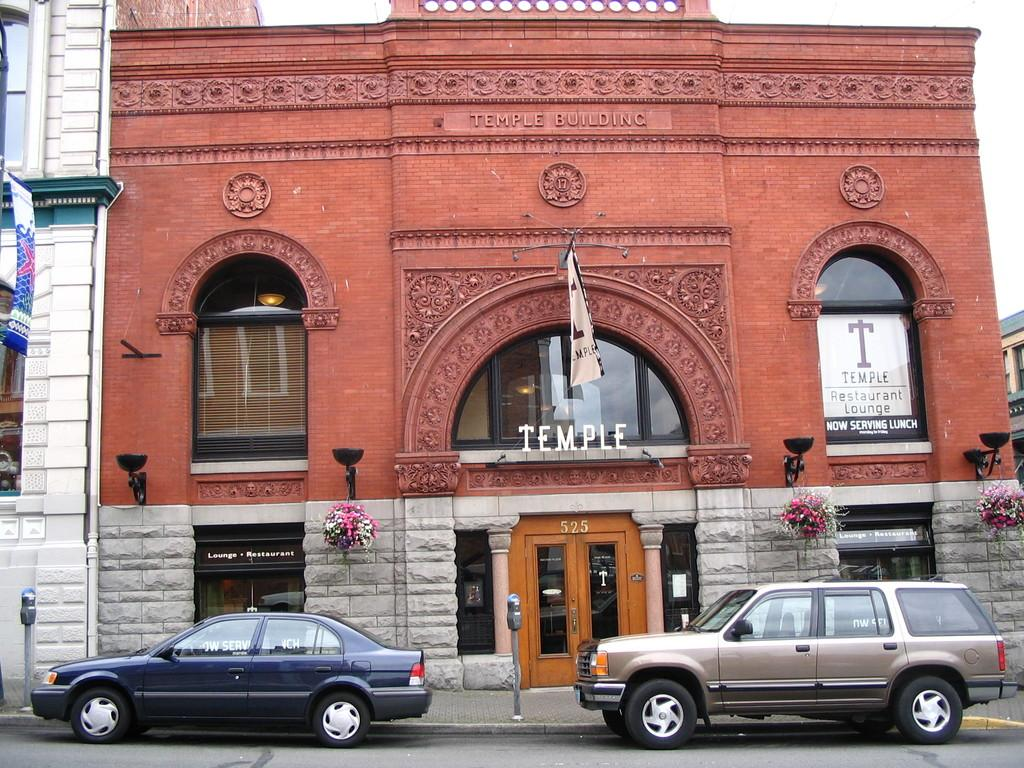What is located in the center of the image? There is a flag on a building in the center of the image. What can be seen on the ground level of the image? Cars are visible on the road at the bottom of the image. Can you describe a feature of the building in the image? There is a door in the image. What type of decorative items are present in the image? Flower vases are present in the image. What allows light to enter the building in the image? Windows are visible in the image. What is visible in the background of the image? The sky is visible in the background of the image. What account number is written on the flag in the image? There is no account number present on the flag in the image. How is the paste being used in the image? There is no paste present in the image. 